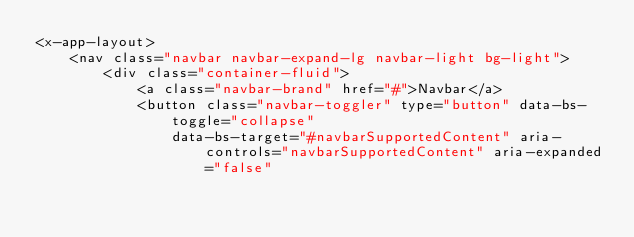Convert code to text. <code><loc_0><loc_0><loc_500><loc_500><_PHP_><x-app-layout>
    <nav class="navbar navbar-expand-lg navbar-light bg-light">
        <div class="container-fluid">
            <a class="navbar-brand" href="#">Navbar</a>
            <button class="navbar-toggler" type="button" data-bs-toggle="collapse"
                data-bs-target="#navbarSupportedContent" aria-controls="navbarSupportedContent" aria-expanded="false"</code> 